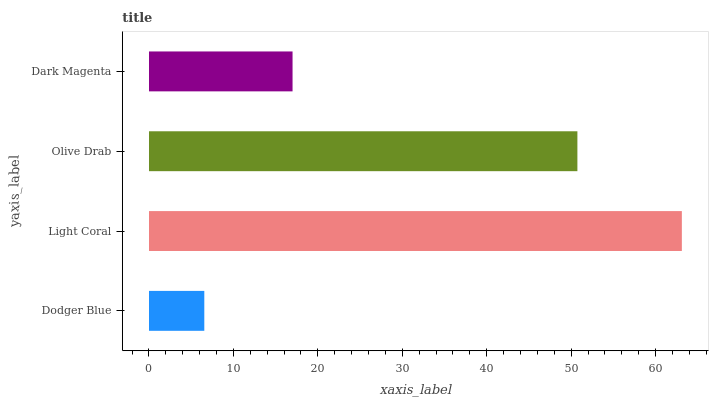Is Dodger Blue the minimum?
Answer yes or no. Yes. Is Light Coral the maximum?
Answer yes or no. Yes. Is Olive Drab the minimum?
Answer yes or no. No. Is Olive Drab the maximum?
Answer yes or no. No. Is Light Coral greater than Olive Drab?
Answer yes or no. Yes. Is Olive Drab less than Light Coral?
Answer yes or no. Yes. Is Olive Drab greater than Light Coral?
Answer yes or no. No. Is Light Coral less than Olive Drab?
Answer yes or no. No. Is Olive Drab the high median?
Answer yes or no. Yes. Is Dark Magenta the low median?
Answer yes or no. Yes. Is Dark Magenta the high median?
Answer yes or no. No. Is Light Coral the low median?
Answer yes or no. No. 